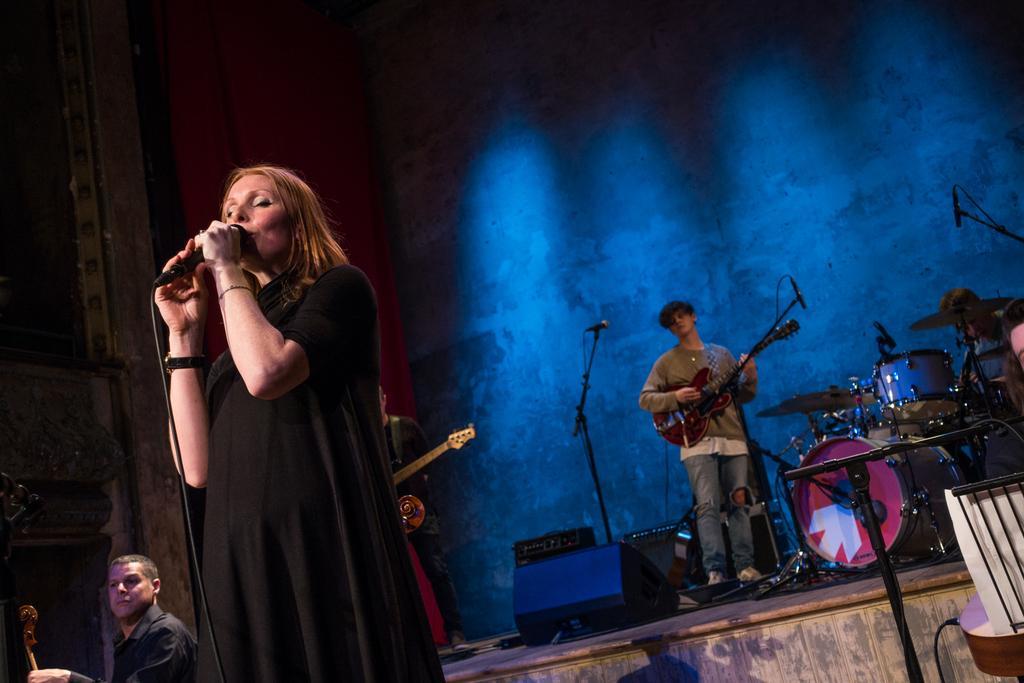In one or two sentences, can you explain what this image depicts? In this image I can see few people are standing where a woman is holding a mic and rest all are holding musical instruments. I can also see a person is sitting next to a drum set. 